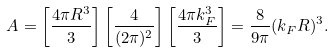<formula> <loc_0><loc_0><loc_500><loc_500>A = \left [ \frac { 4 \pi R ^ { 3 } } { 3 } \right ] \left [ \frac { 4 } { ( 2 \pi ) ^ { 2 } } \right ] \left [ \frac { 4 \pi k _ { F } ^ { 3 } } { 3 } \right ] = \frac { 8 } { 9 \pi } ( k _ { F } R ) ^ { 3 } .</formula> 